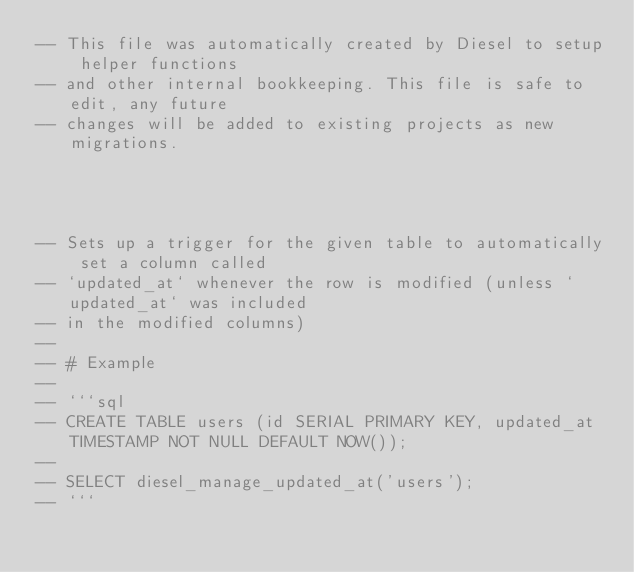<code> <loc_0><loc_0><loc_500><loc_500><_SQL_>-- This file was automatically created by Diesel to setup helper functions
-- and other internal bookkeeping. This file is safe to edit, any future
-- changes will be added to existing projects as new migrations.




-- Sets up a trigger for the given table to automatically set a column called
-- `updated_at` whenever the row is modified (unless `updated_at` was included
-- in the modified columns)
--
-- # Example
--
-- ```sql
-- CREATE TABLE users (id SERIAL PRIMARY KEY, updated_at TIMESTAMP NOT NULL DEFAULT NOW());
--
-- SELECT diesel_manage_updated_at('users');
-- ```

</code> 